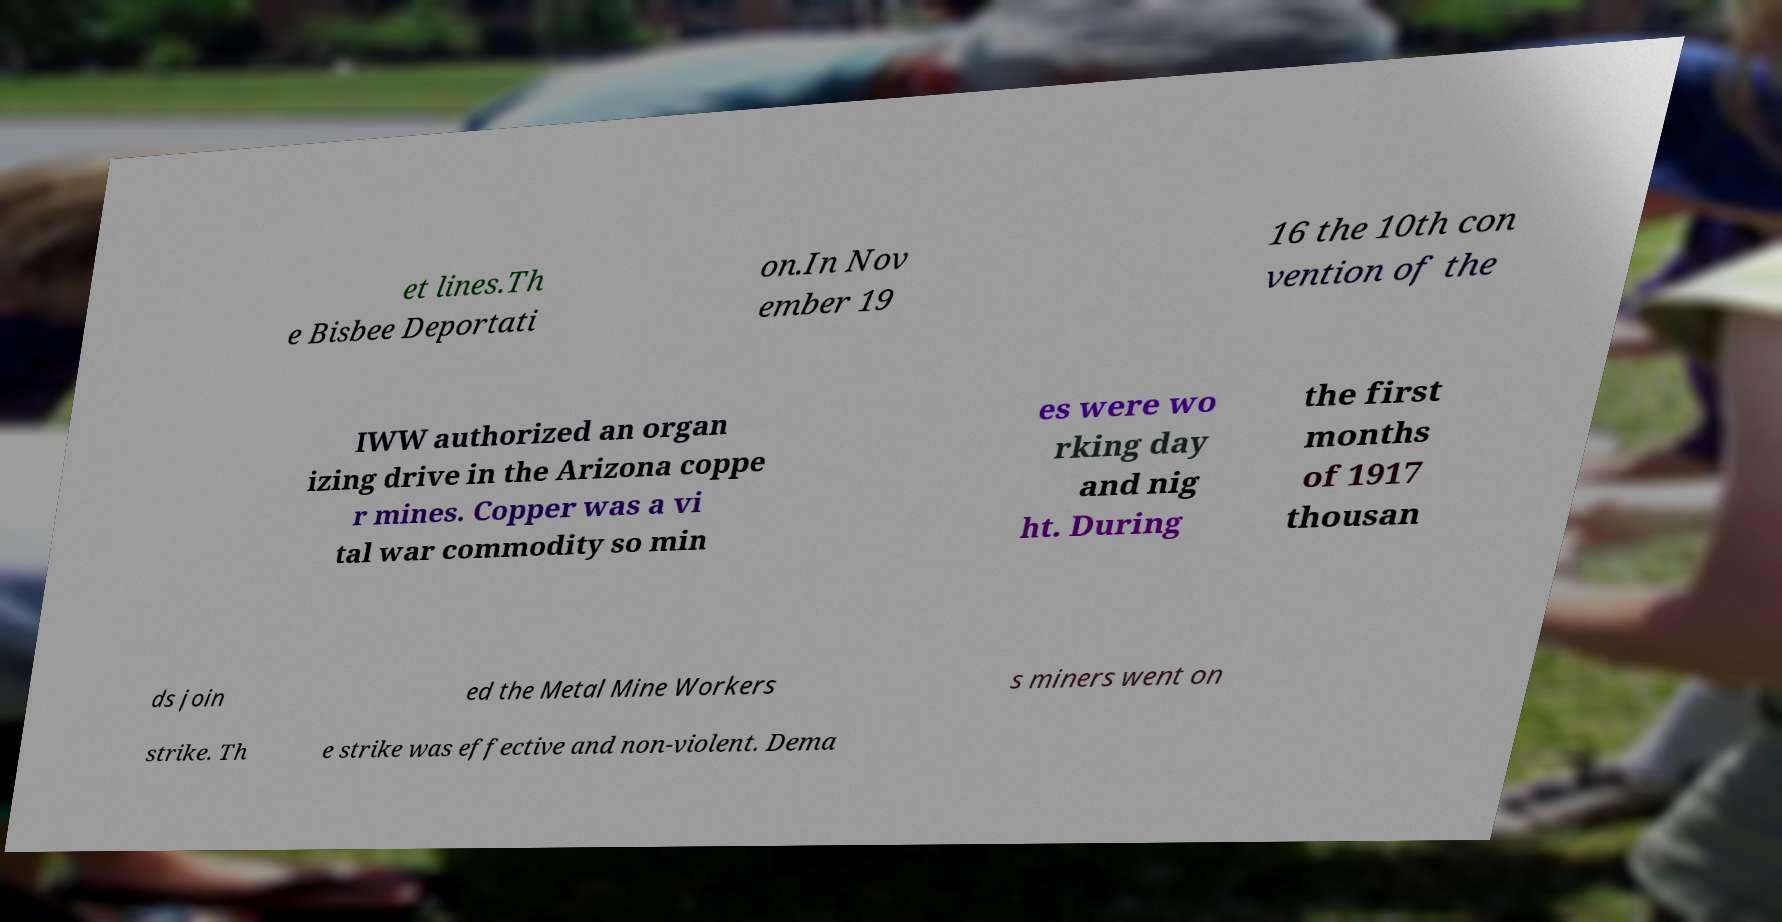Could you assist in decoding the text presented in this image and type it out clearly? et lines.Th e Bisbee Deportati on.In Nov ember 19 16 the 10th con vention of the IWW authorized an organ izing drive in the Arizona coppe r mines. Copper was a vi tal war commodity so min es were wo rking day and nig ht. During the first months of 1917 thousan ds join ed the Metal Mine Workers s miners went on strike. Th e strike was effective and non-violent. Dema 